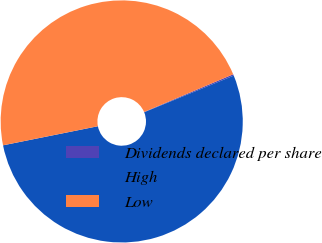<chart> <loc_0><loc_0><loc_500><loc_500><pie_chart><fcel>Dividends declared per share<fcel>High<fcel>Low<nl><fcel>0.19%<fcel>53.02%<fcel>46.79%<nl></chart> 